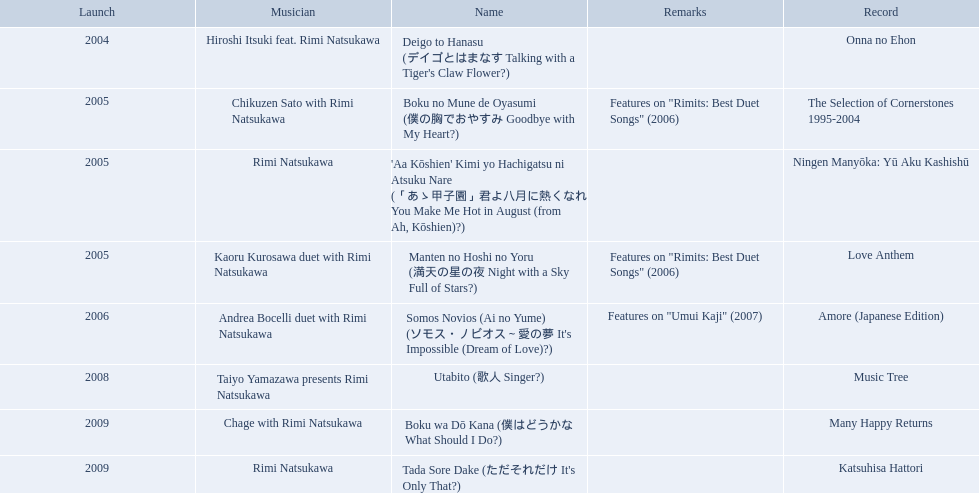What year was onna no ehon released? 2004. What year was music tree released? 2008. Which of the two was not released in 2004? Music Tree. 